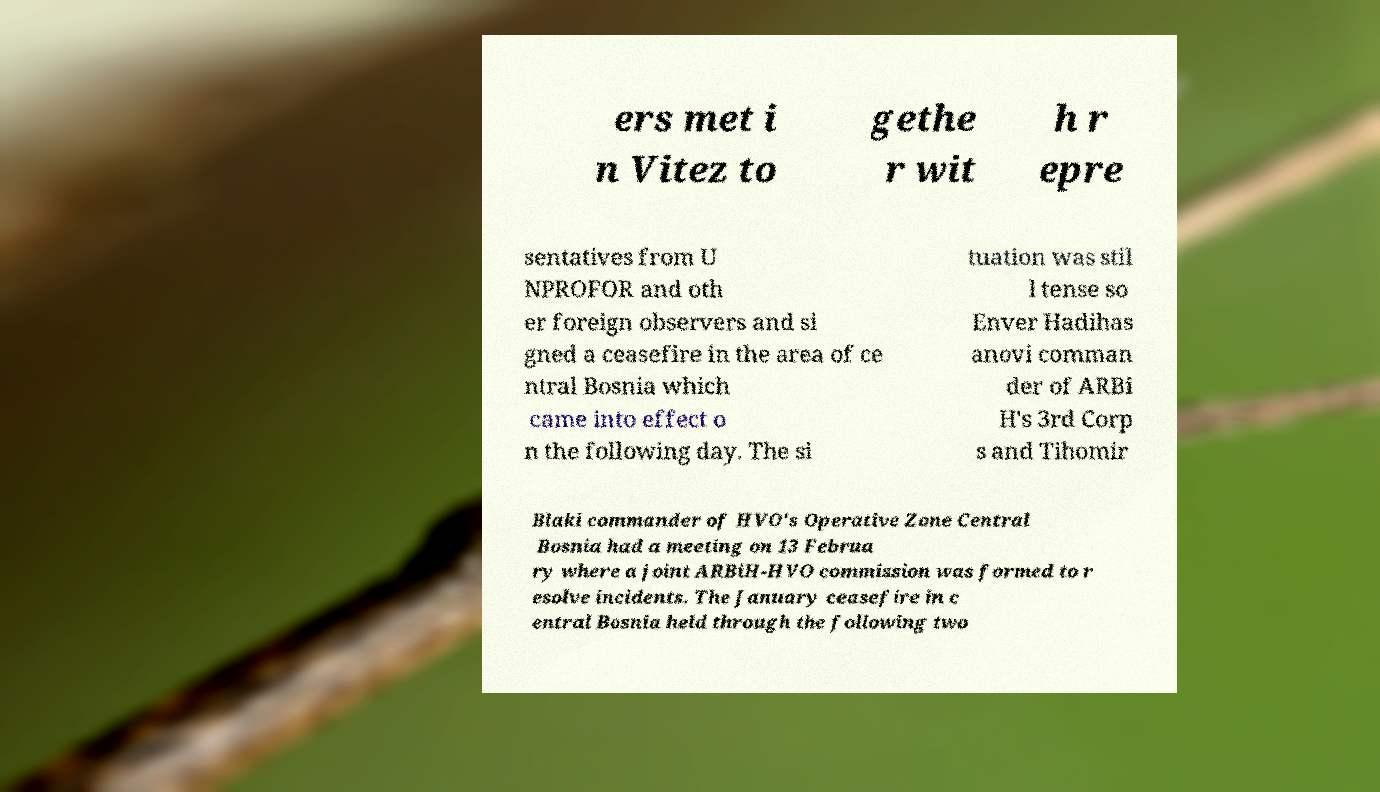Can you accurately transcribe the text from the provided image for me? ers met i n Vitez to gethe r wit h r epre sentatives from U NPROFOR and oth er foreign observers and si gned a ceasefire in the area of ce ntral Bosnia which came into effect o n the following day. The si tuation was stil l tense so Enver Hadihas anovi comman der of ARBi H's 3rd Corp s and Tihomir Blaki commander of HVO's Operative Zone Central Bosnia had a meeting on 13 Februa ry where a joint ARBiH-HVO commission was formed to r esolve incidents. The January ceasefire in c entral Bosnia held through the following two 